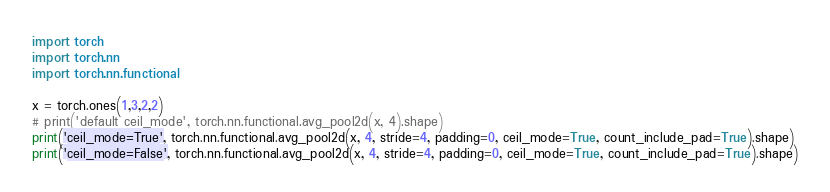<code> <loc_0><loc_0><loc_500><loc_500><_Python_>import torch
import torch.nn
import torch.nn.functional

x = torch.ones(1,3,2,2)
# print('default ceil_mode', torch.nn.functional.avg_pool2d(x, 4).shape)
print('ceil_mode=True', torch.nn.functional.avg_pool2d(x, 4, stride=4, padding=0, ceil_mode=True, count_include_pad=True).shape)
print('ceil_mode=False', torch.nn.functional.avg_pool2d(x, 4, stride=4, padding=0, ceil_mode=True, count_include_pad=True).shape)</code> 